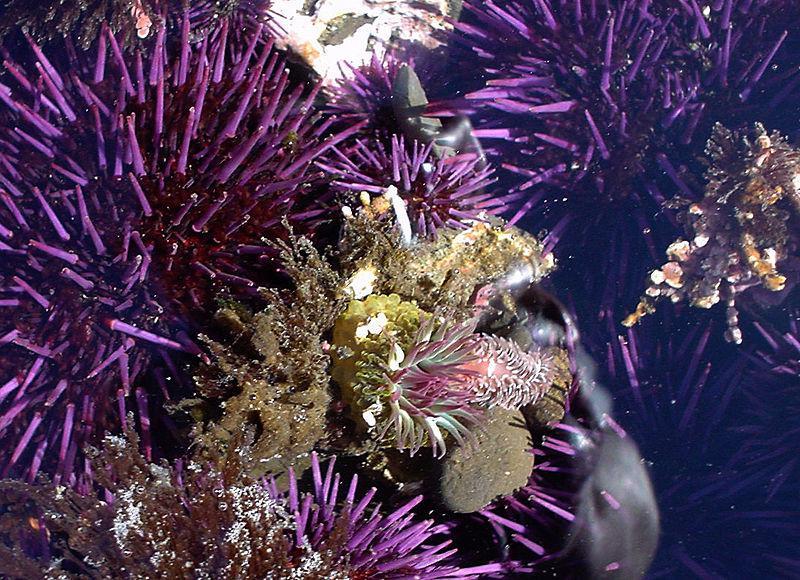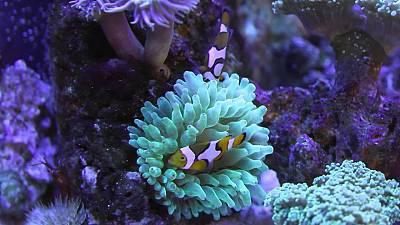The first image is the image on the left, the second image is the image on the right. Assess this claim about the two images: "In at least one image, there is a single purple round corral underneath green corral arms that fish are swimming through.". Correct or not? Answer yes or no. No. The first image is the image on the left, the second image is the image on the right. Examine the images to the left and right. Is the description "The right image shows at least two orange fish swimming in tendrils that sprout from an anemone's round purple stalk." accurate? Answer yes or no. No. 